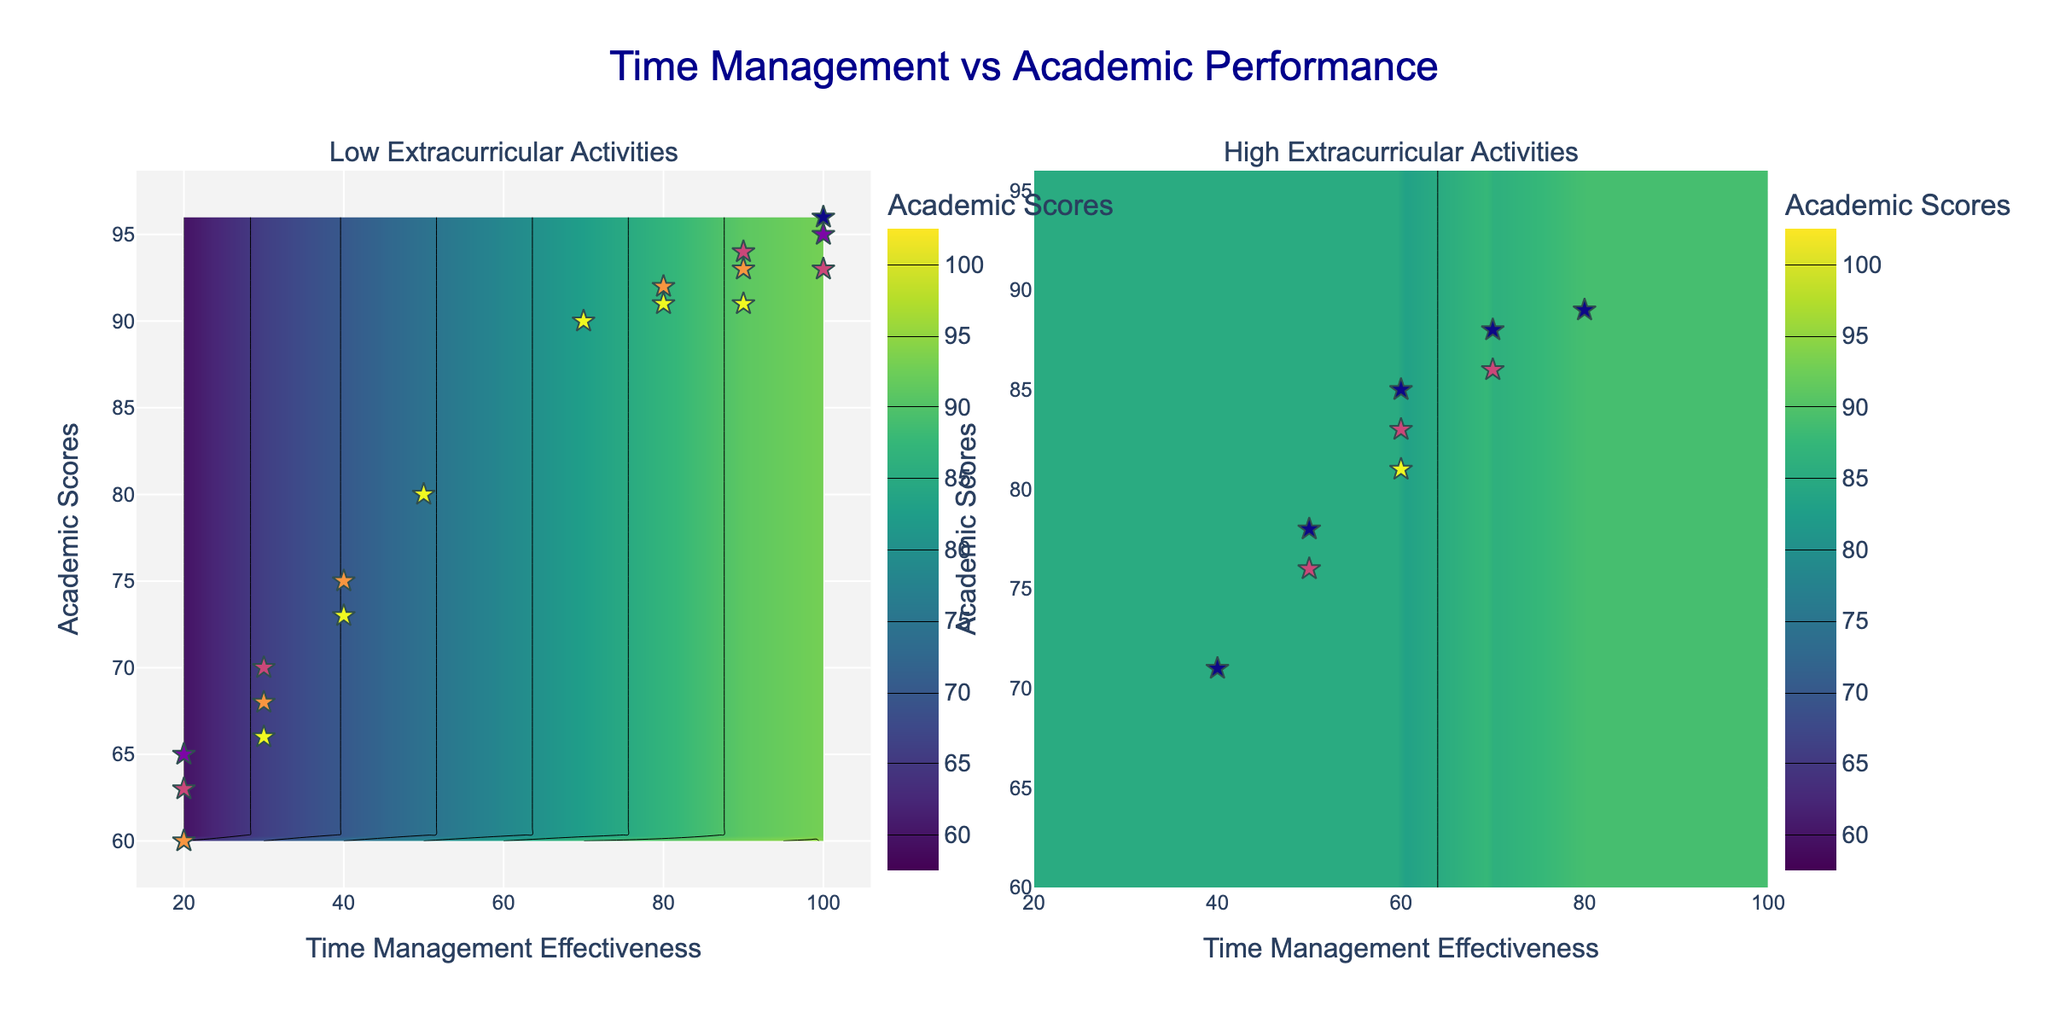What is the title of the figure? The title is typically located at the top of the figure in a larger font and often describes the main topic. In this case, it says "Time Management vs Academic Performance".
Answer: Time Management vs Academic Performance What are the x-axis and y-axis titles in the figure? The x-axis title is generally at the bottom along the horizontal axis, and the y-axis title is along the vertical axis. They respectively state "Time Management Effectiveness" and "Academic Scores".
Answer: Time Management Effectiveness, Academic Scores How many subplots are present in the figure? A subplot is a smaller plot within the figure, each with its own axes and data. The figure has two subplots side by side.
Answer: 2 Which subplot represents students with higher extracurricular activities? To find this, look at the titles of the subplots. The subplot titled "High Extracurricular Activities" represents students with higher extracurricular activities.
Answer: The right one Which range of colors indicates higher academic scores? The color scale in the contour plot shows that darker colors, typically seen in the upper part of the figure, indicate higher academic scores.
Answer: Darker colors How does time management effectiveness generally affect academic scores in the low extracurricular activities group? From the left subplot, observe the trend that as time management effectiveness increases from left to right, the academic scores also increase, indicated by the rising contour lines.
Answer: Increases Are there more students with mid-level extracurricular activities in the low or high group? By observing the scatter points on both subplots and their color coding from the scale, more mid-level (closer to median) extracurricular activities appear more densely populated in the left subplot.
Answer: Low group Which group shows a sharper increase in academic scores as time management improves? Compare the steepness of the contour lines in both subplots. The right subplot has closer contour lines indicating a sharper increase in academic scores with better time management.
Answer: High extracurricular activities Is there any student with perfect time management effectiveness but low extracurricular activity? Look for scatter points along the far right of the x-axis in the left subplot. There indeed are students with perfect time management (100) and low extracurricular activities.
Answer: Yes What is the range of academic scores in the high extracurricular activities group? Look at the contour levels and scatter points in the right subplot which indicate that academic scores range from about 60 to 100.
Answer: 60 to 100 